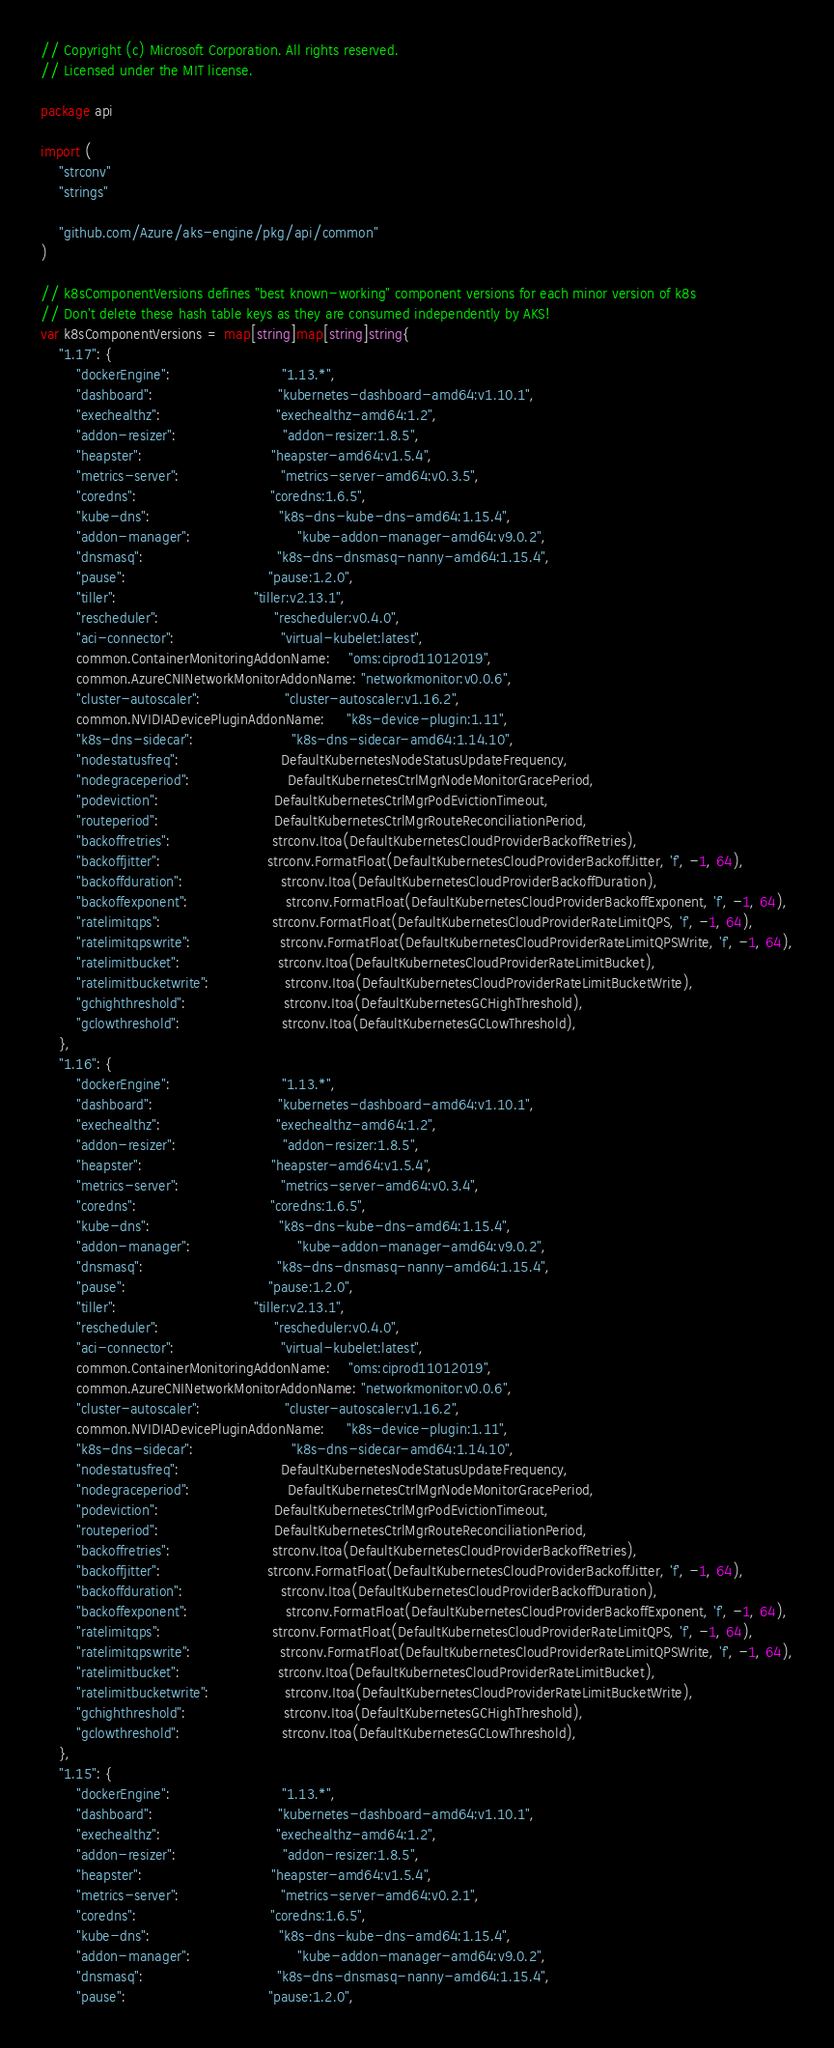Convert code to text. <code><loc_0><loc_0><loc_500><loc_500><_Go_>// Copyright (c) Microsoft Corporation. All rights reserved.
// Licensed under the MIT license.

package api

import (
	"strconv"
	"strings"

	"github.com/Azure/aks-engine/pkg/api/common"
)

// k8sComponentVersions defines "best known-working" component versions for each minor version of k8s
// Don't delete these hash table keys as they are consumed independently by AKS!
var k8sComponentVersions = map[string]map[string]string{
	"1.17": {
		"dockerEngine":                         "1.13.*",
		"dashboard":                            "kubernetes-dashboard-amd64:v1.10.1",
		"exechealthz":                          "exechealthz-amd64:1.2",
		"addon-resizer":                        "addon-resizer:1.8.5",
		"heapster":                             "heapster-amd64:v1.5.4",
		"metrics-server":                       "metrics-server-amd64:v0.3.5",
		"coredns":                              "coredns:1.6.5",
		"kube-dns":                             "k8s-dns-kube-dns-amd64:1.15.4",
		"addon-manager":                        "kube-addon-manager-amd64:v9.0.2",
		"dnsmasq":                              "k8s-dns-dnsmasq-nanny-amd64:1.15.4",
		"pause":                                "pause:1.2.0",
		"tiller":                               "tiller:v2.13.1",
		"rescheduler":                          "rescheduler:v0.4.0",
		"aci-connector":                        "virtual-kubelet:latest",
		common.ContainerMonitoringAddonName:    "oms:ciprod11012019",
		common.AzureCNINetworkMonitorAddonName: "networkmonitor:v0.0.6",
		"cluster-autoscaler":                   "cluster-autoscaler:v1.16.2",
		common.NVIDIADevicePluginAddonName:     "k8s-device-plugin:1.11",
		"k8s-dns-sidecar":                      "k8s-dns-sidecar-amd64:1.14.10",
		"nodestatusfreq":                       DefaultKubernetesNodeStatusUpdateFrequency,
		"nodegraceperiod":                      DefaultKubernetesCtrlMgrNodeMonitorGracePeriod,
		"podeviction":                          DefaultKubernetesCtrlMgrPodEvictionTimeout,
		"routeperiod":                          DefaultKubernetesCtrlMgrRouteReconciliationPeriod,
		"backoffretries":                       strconv.Itoa(DefaultKubernetesCloudProviderBackoffRetries),
		"backoffjitter":                        strconv.FormatFloat(DefaultKubernetesCloudProviderBackoffJitter, 'f', -1, 64),
		"backoffduration":                      strconv.Itoa(DefaultKubernetesCloudProviderBackoffDuration),
		"backoffexponent":                      strconv.FormatFloat(DefaultKubernetesCloudProviderBackoffExponent, 'f', -1, 64),
		"ratelimitqps":                         strconv.FormatFloat(DefaultKubernetesCloudProviderRateLimitQPS, 'f', -1, 64),
		"ratelimitqpswrite":                    strconv.FormatFloat(DefaultKubernetesCloudProviderRateLimitQPSWrite, 'f', -1, 64),
		"ratelimitbucket":                      strconv.Itoa(DefaultKubernetesCloudProviderRateLimitBucket),
		"ratelimitbucketwrite":                 strconv.Itoa(DefaultKubernetesCloudProviderRateLimitBucketWrite),
		"gchighthreshold":                      strconv.Itoa(DefaultKubernetesGCHighThreshold),
		"gclowthreshold":                       strconv.Itoa(DefaultKubernetesGCLowThreshold),
	},
	"1.16": {
		"dockerEngine":                         "1.13.*",
		"dashboard":                            "kubernetes-dashboard-amd64:v1.10.1",
		"exechealthz":                          "exechealthz-amd64:1.2",
		"addon-resizer":                        "addon-resizer:1.8.5",
		"heapster":                             "heapster-amd64:v1.5.4",
		"metrics-server":                       "metrics-server-amd64:v0.3.4",
		"coredns":                              "coredns:1.6.5",
		"kube-dns":                             "k8s-dns-kube-dns-amd64:1.15.4",
		"addon-manager":                        "kube-addon-manager-amd64:v9.0.2",
		"dnsmasq":                              "k8s-dns-dnsmasq-nanny-amd64:1.15.4",
		"pause":                                "pause:1.2.0",
		"tiller":                               "tiller:v2.13.1",
		"rescheduler":                          "rescheduler:v0.4.0",
		"aci-connector":                        "virtual-kubelet:latest",
		common.ContainerMonitoringAddonName:    "oms:ciprod11012019",
		common.AzureCNINetworkMonitorAddonName: "networkmonitor:v0.0.6",
		"cluster-autoscaler":                   "cluster-autoscaler:v1.16.2",
		common.NVIDIADevicePluginAddonName:     "k8s-device-plugin:1.11",
		"k8s-dns-sidecar":                      "k8s-dns-sidecar-amd64:1.14.10",
		"nodestatusfreq":                       DefaultKubernetesNodeStatusUpdateFrequency,
		"nodegraceperiod":                      DefaultKubernetesCtrlMgrNodeMonitorGracePeriod,
		"podeviction":                          DefaultKubernetesCtrlMgrPodEvictionTimeout,
		"routeperiod":                          DefaultKubernetesCtrlMgrRouteReconciliationPeriod,
		"backoffretries":                       strconv.Itoa(DefaultKubernetesCloudProviderBackoffRetries),
		"backoffjitter":                        strconv.FormatFloat(DefaultKubernetesCloudProviderBackoffJitter, 'f', -1, 64),
		"backoffduration":                      strconv.Itoa(DefaultKubernetesCloudProviderBackoffDuration),
		"backoffexponent":                      strconv.FormatFloat(DefaultKubernetesCloudProviderBackoffExponent, 'f', -1, 64),
		"ratelimitqps":                         strconv.FormatFloat(DefaultKubernetesCloudProviderRateLimitQPS, 'f', -1, 64),
		"ratelimitqpswrite":                    strconv.FormatFloat(DefaultKubernetesCloudProviderRateLimitQPSWrite, 'f', -1, 64),
		"ratelimitbucket":                      strconv.Itoa(DefaultKubernetesCloudProviderRateLimitBucket),
		"ratelimitbucketwrite":                 strconv.Itoa(DefaultKubernetesCloudProviderRateLimitBucketWrite),
		"gchighthreshold":                      strconv.Itoa(DefaultKubernetesGCHighThreshold),
		"gclowthreshold":                       strconv.Itoa(DefaultKubernetesGCLowThreshold),
	},
	"1.15": {
		"dockerEngine":                         "1.13.*",
		"dashboard":                            "kubernetes-dashboard-amd64:v1.10.1",
		"exechealthz":                          "exechealthz-amd64:1.2",
		"addon-resizer":                        "addon-resizer:1.8.5",
		"heapster":                             "heapster-amd64:v1.5.4",
		"metrics-server":                       "metrics-server-amd64:v0.2.1",
		"coredns":                              "coredns:1.6.5",
		"kube-dns":                             "k8s-dns-kube-dns-amd64:1.15.4",
		"addon-manager":                        "kube-addon-manager-amd64:v9.0.2",
		"dnsmasq":                              "k8s-dns-dnsmasq-nanny-amd64:1.15.4",
		"pause":                                "pause:1.2.0",</code> 